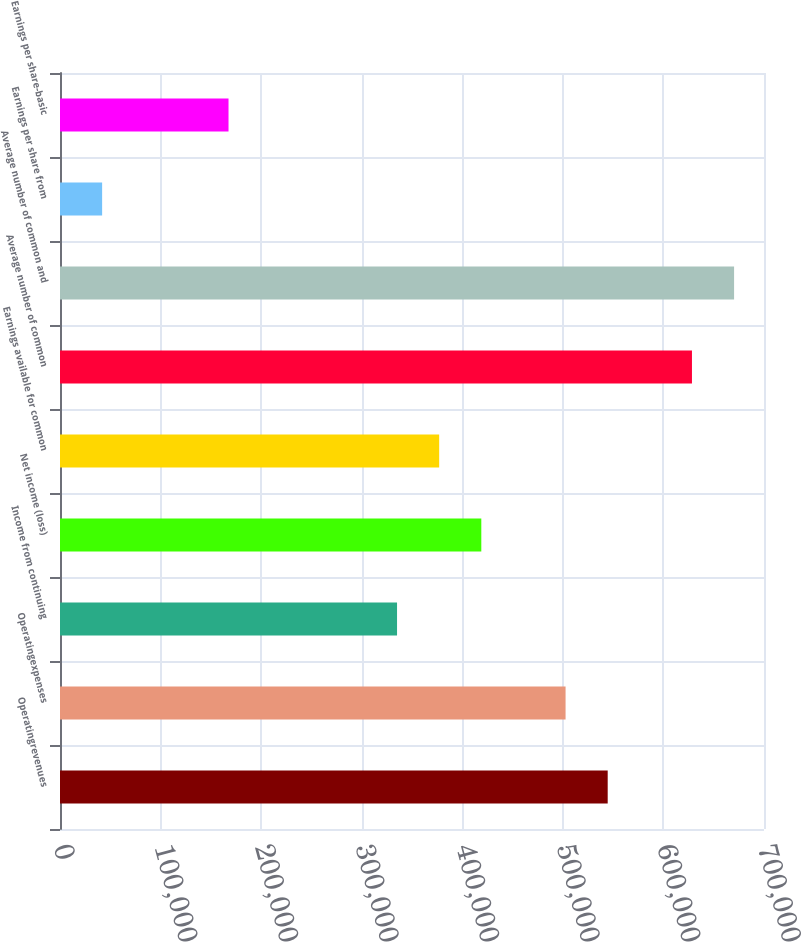Convert chart. <chart><loc_0><loc_0><loc_500><loc_500><bar_chart><fcel>Operatingrevenues<fcel>Operatingexpenses<fcel>Income from continuing<fcel>Net income (loss)<fcel>Earnings available for common<fcel>Average number of common<fcel>Average number of common and<fcel>Earnings per share from<fcel>Earnings per share-basic<nl><fcel>544585<fcel>502694<fcel>335130<fcel>418912<fcel>377021<fcel>628368<fcel>670259<fcel>41891.9<fcel>167565<nl></chart> 